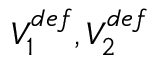<formula> <loc_0><loc_0><loc_500><loc_500>V _ { 1 } ^ { d e f } , V _ { 2 } ^ { d e f }</formula> 